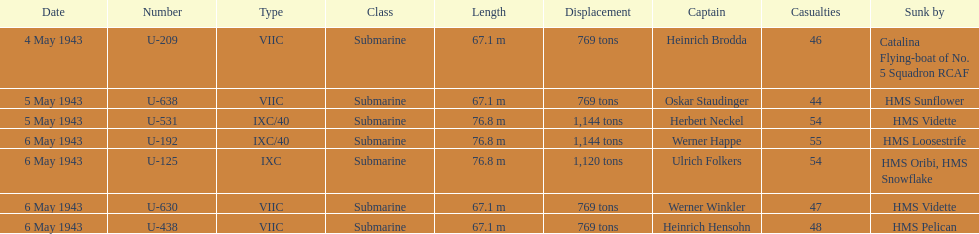Which u-boat was the first to sink U-209. 